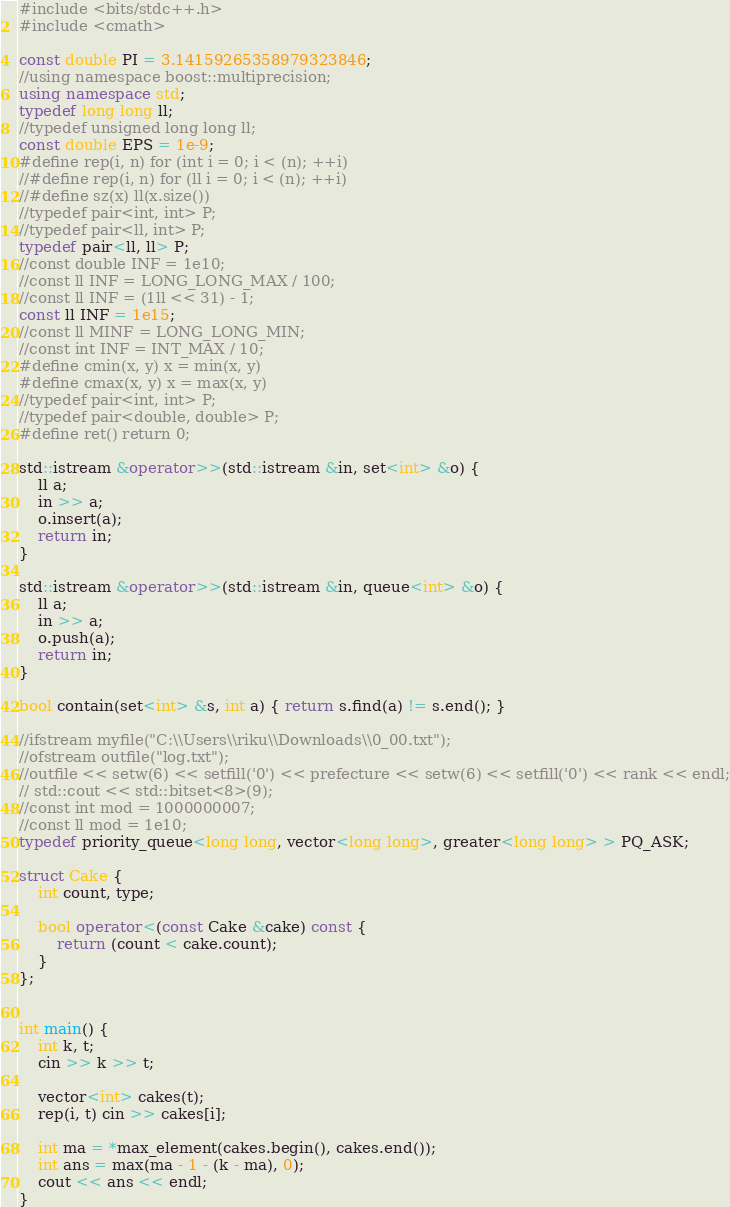Convert code to text. <code><loc_0><loc_0><loc_500><loc_500><_C++_>#include <bits/stdc++.h>
#include <cmath>

const double PI = 3.14159265358979323846;
//using namespace boost::multiprecision;
using namespace std;
typedef long long ll;
//typedef unsigned long long ll;
const double EPS = 1e-9;
#define rep(i, n) for (int i = 0; i < (n); ++i)
//#define rep(i, n) for (ll i = 0; i < (n); ++i)
//#define sz(x) ll(x.size())
//typedef pair<int, int> P;
//typedef pair<ll, int> P;
typedef pair<ll, ll> P;
//const double INF = 1e10;
//const ll INF = LONG_LONG_MAX / 100;
//const ll INF = (1ll << 31) - 1;
const ll INF = 1e15;
//const ll MINF = LONG_LONG_MIN;
//const int INF = INT_MAX / 10;
#define cmin(x, y) x = min(x, y)
#define cmax(x, y) x = max(x, y)
//typedef pair<int, int> P;
//typedef pair<double, double> P;
#define ret() return 0;

std::istream &operator>>(std::istream &in, set<int> &o) {
    ll a;
    in >> a;
    o.insert(a);
    return in;
}

std::istream &operator>>(std::istream &in, queue<int> &o) {
    ll a;
    in >> a;
    o.push(a);
    return in;
}

bool contain(set<int> &s, int a) { return s.find(a) != s.end(); }

//ifstream myfile("C:\\Users\\riku\\Downloads\\0_00.txt");
//ofstream outfile("log.txt");
//outfile << setw(6) << setfill('0') << prefecture << setw(6) << setfill('0') << rank << endl;
// std::cout << std::bitset<8>(9);
//const int mod = 1000000007;
//const ll mod = 1e10;
typedef priority_queue<long long, vector<long long>, greater<long long> > PQ_ASK;

struct Cake {
    int count, type;

    bool operator<(const Cake &cake) const {
        return (count < cake.count);
    }
};


int main() {
    int k, t;
    cin >> k >> t;

    vector<int> cakes(t);
    rep(i, t) cin >> cakes[i];

    int ma = *max_element(cakes.begin(), cakes.end());
    int ans = max(ma - 1 - (k - ma), 0);
    cout << ans << endl;
}
</code> 